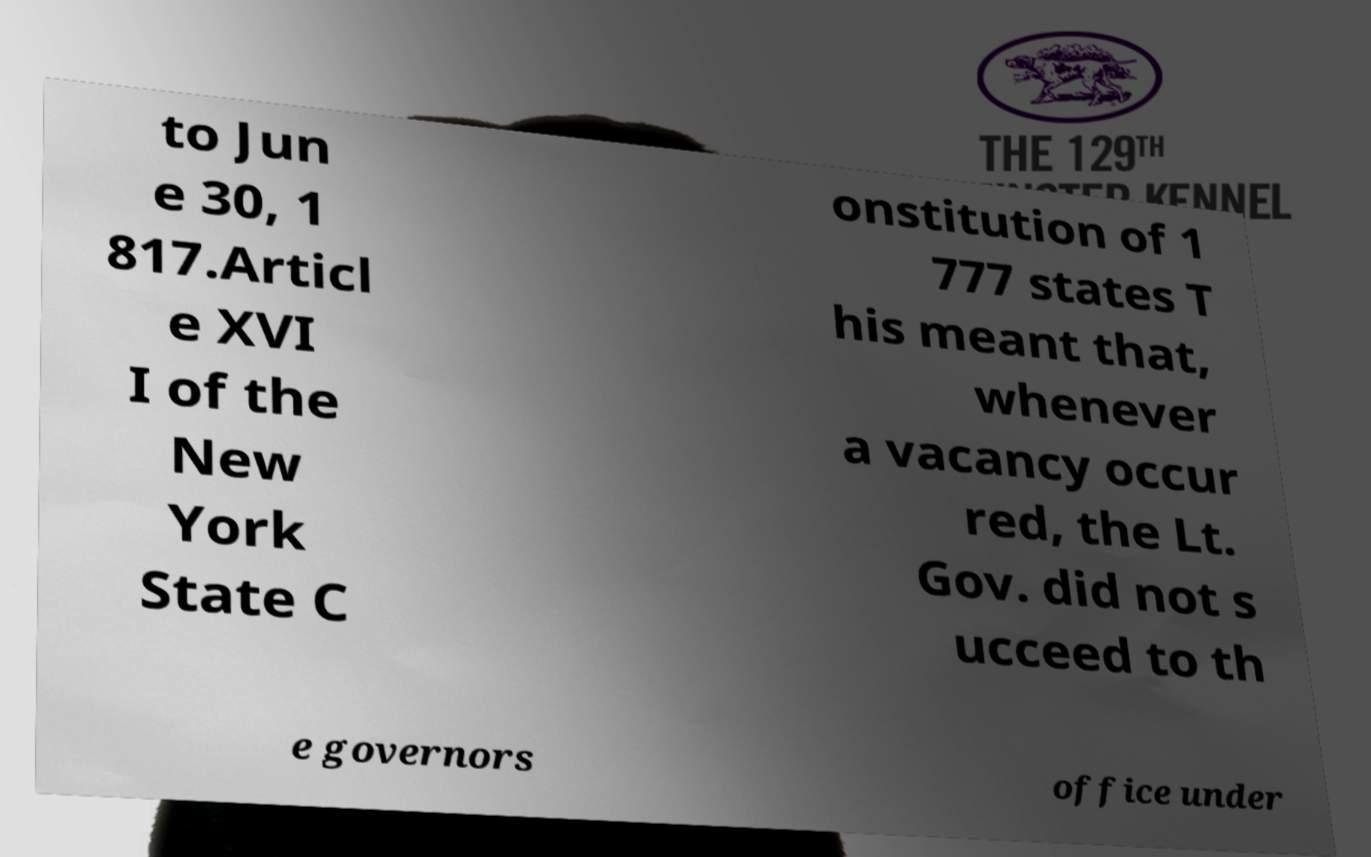Could you extract and type out the text from this image? to Jun e 30, 1 817.Articl e XVI I of the New York State C onstitution of 1 777 states T his meant that, whenever a vacancy occur red, the Lt. Gov. did not s ucceed to th e governors office under 